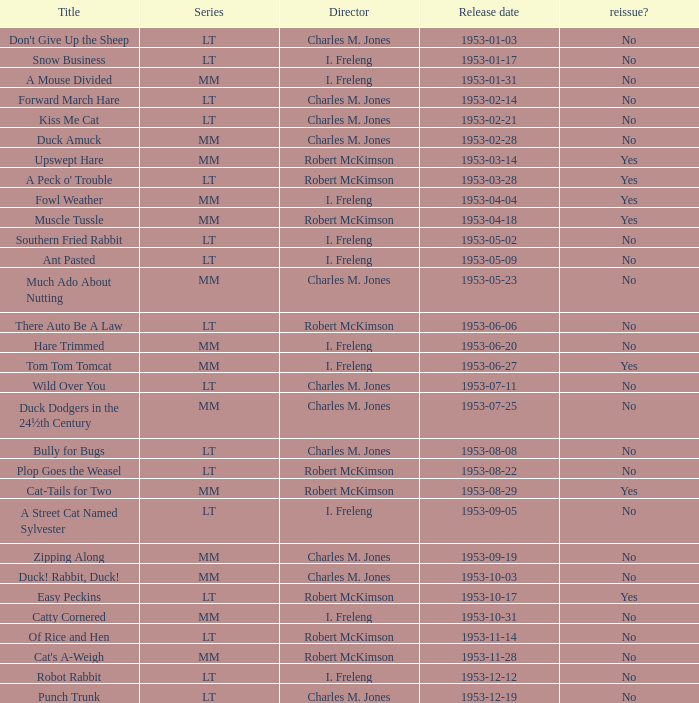What's the lineup of kiss me cat series? LT. 